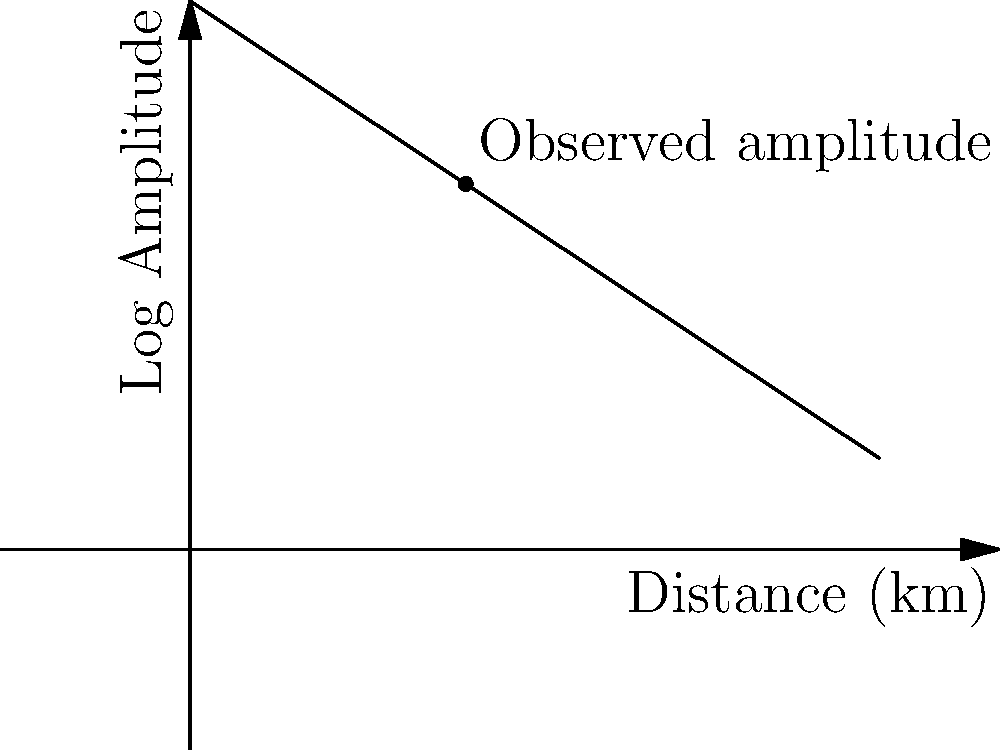Using the amplitude-distance relationship graph for a specific seismic event, estimate the magnitude of the earthquake if an amplitude of $10^2$ units was recorded at a distance of 2 km from the epicenter. Assume the y-intercept represents a magnitude 6 earthquake. To solve this problem, we'll follow these steps:

1) First, note that the y-axis is in log scale. The observed amplitude of $10^2$ corresponds to a log amplitude of 2.

2) From the graph, we can see that this point (2 km, log amplitude 2) lies exactly on the line.

3) The y-intercept of the line represents a magnitude 6 earthquake. This means that at 0 km (at the epicenter), an amplitude corresponding to log amplitude 3 would be a magnitude 6 earthquake.

4) The slope of the line represents how the amplitude decreases with distance. We don't need to calculate this explicitly.

5) What we need to determine is how the observed amplitude at 2 km relates to the amplitude at 0 km (the y-intercept).

6) The difference in log amplitude between the y-intercept (3) and our observed point (2) is 1 log unit.

7) In earthquake magnitude scales, a difference of 1 in log amplitude corresponds to 1 unit of magnitude.

8) Therefore, our observed earthquake is 1 magnitude unit less than the reference magnitude 6 earthquake.

9) Thus, the estimated magnitude of the observed earthquake is 6 - 1 = 5.
Answer: Magnitude 5 